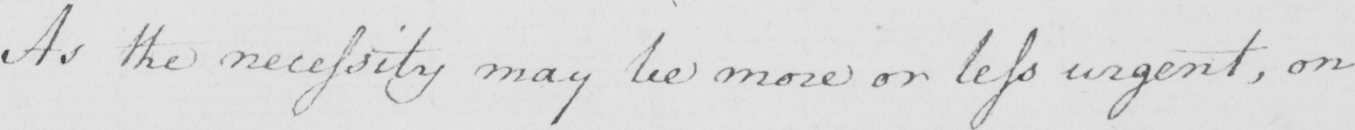Please transcribe the handwritten text in this image. As the necessity may be more or less urgent , on 